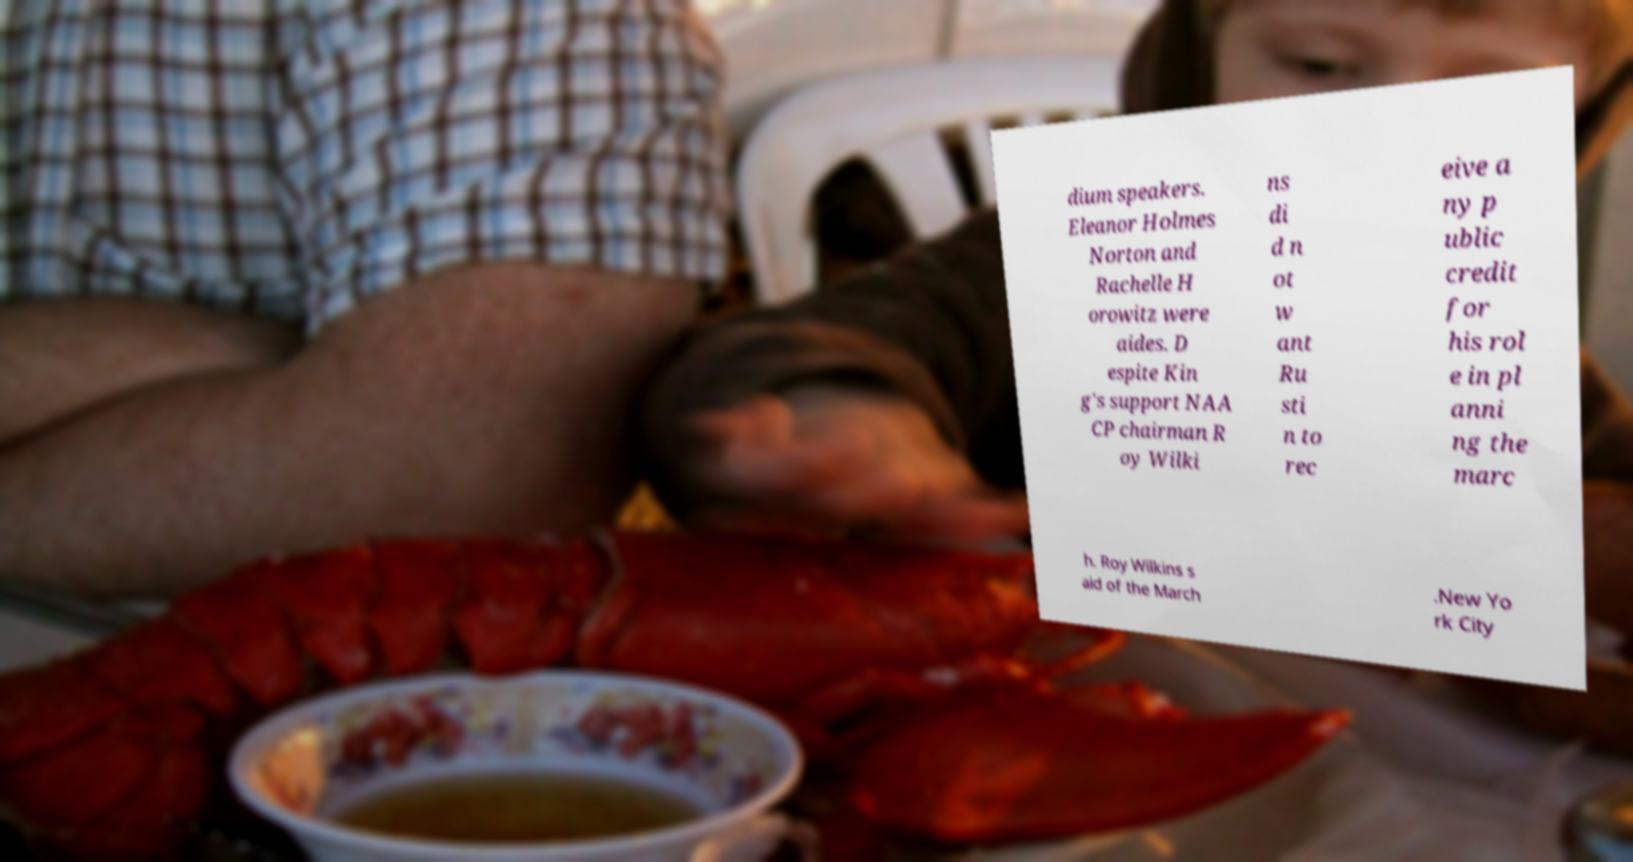Could you assist in decoding the text presented in this image and type it out clearly? dium speakers. Eleanor Holmes Norton and Rachelle H orowitz were aides. D espite Kin g's support NAA CP chairman R oy Wilki ns di d n ot w ant Ru sti n to rec eive a ny p ublic credit for his rol e in pl anni ng the marc h. Roy Wilkins s aid of the March .New Yo rk City 